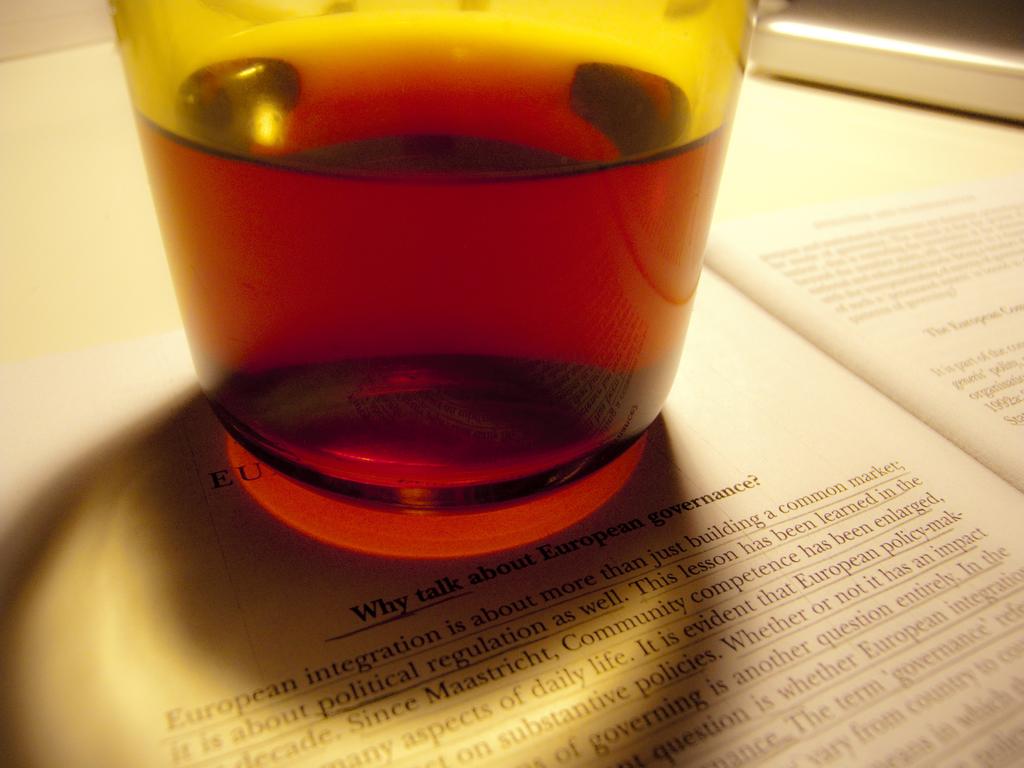Why talk about what?
Offer a terse response. European governance. 